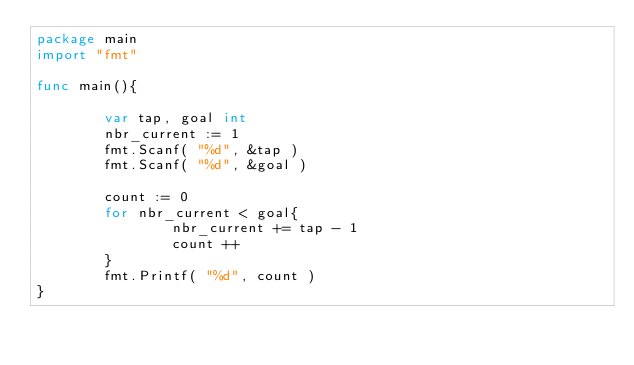<code> <loc_0><loc_0><loc_500><loc_500><_Go_>package main
import "fmt"

func main(){

        var tap, goal int
        nbr_current := 1
        fmt.Scanf( "%d", &tap )
        fmt.Scanf( "%d", &goal )

        count := 0
        for nbr_current < goal{
                nbr_current += tap - 1
                count ++
        }
        fmt.Printf( "%d", count )
}</code> 